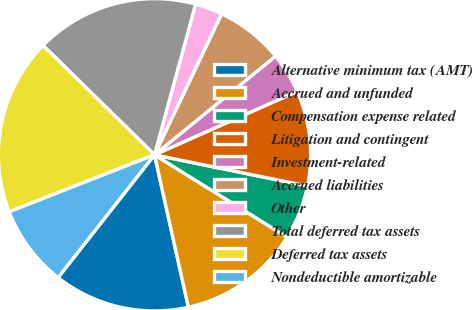<chart> <loc_0><loc_0><loc_500><loc_500><pie_chart><fcel>Alternative minimum tax (AMT)<fcel>Accrued and unfunded<fcel>Compensation expense related<fcel>Litigation and contingent<fcel>Investment-related<fcel>Accrued liabilities<fcel>Other<fcel>Total deferred tax assets<fcel>Deferred tax assets<fcel>Nondeductible amortizable<nl><fcel>14.08%<fcel>12.67%<fcel>5.64%<fcel>9.86%<fcel>4.23%<fcel>7.05%<fcel>2.83%<fcel>16.89%<fcel>18.3%<fcel>8.45%<nl></chart> 